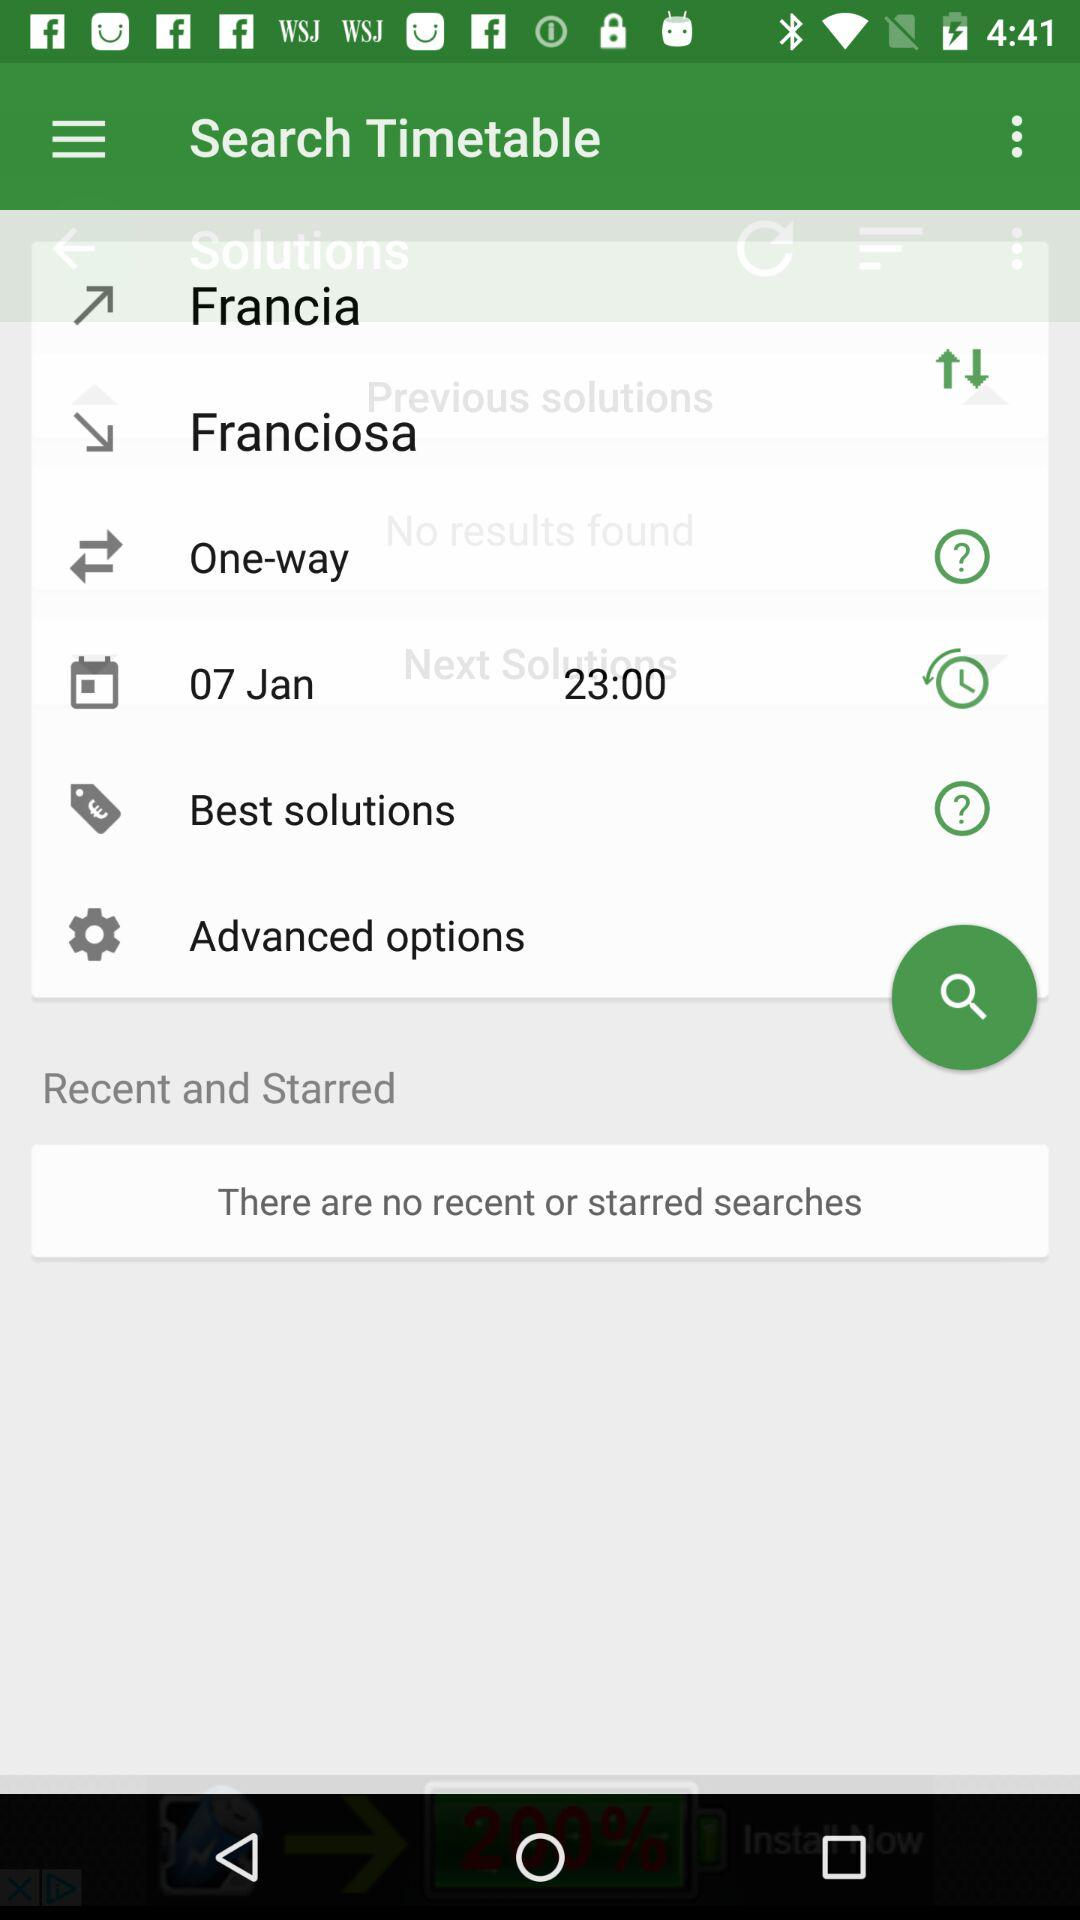What is the selected date? The selected date is January 07. 